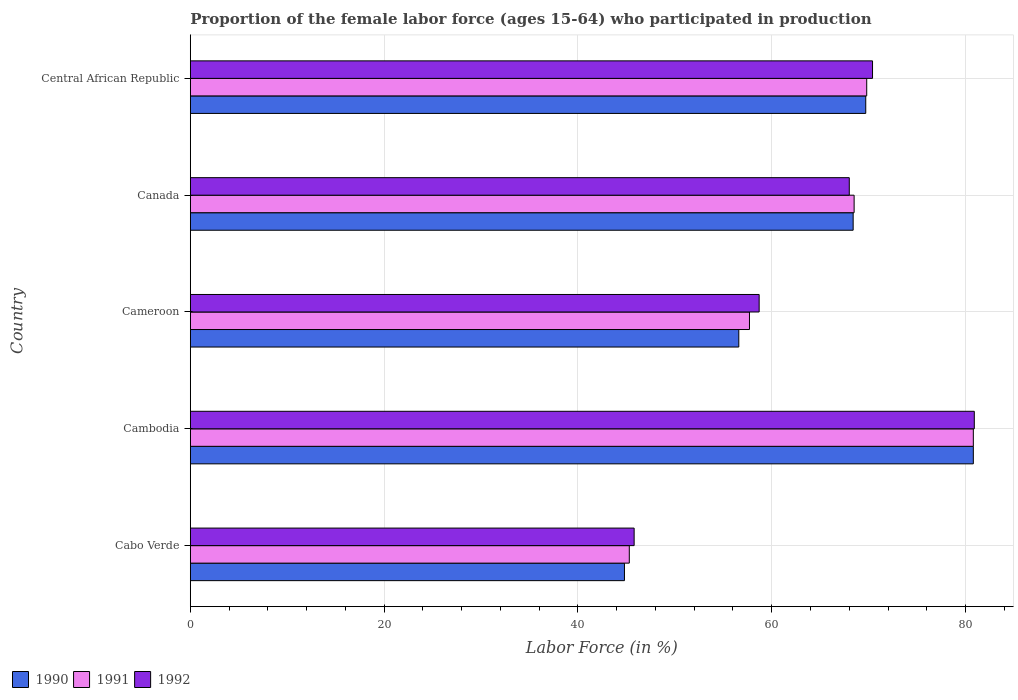How many different coloured bars are there?
Keep it short and to the point. 3. Are the number of bars per tick equal to the number of legend labels?
Offer a very short reply. Yes. Are the number of bars on each tick of the Y-axis equal?
Offer a terse response. Yes. What is the label of the 5th group of bars from the top?
Provide a succinct answer. Cabo Verde. In how many cases, is the number of bars for a given country not equal to the number of legend labels?
Keep it short and to the point. 0. What is the proportion of the female labor force who participated in production in 1992 in Cambodia?
Keep it short and to the point. 80.9. Across all countries, what is the maximum proportion of the female labor force who participated in production in 1991?
Your answer should be compact. 80.8. Across all countries, what is the minimum proportion of the female labor force who participated in production in 1992?
Provide a succinct answer. 45.8. In which country was the proportion of the female labor force who participated in production in 1991 maximum?
Keep it short and to the point. Cambodia. In which country was the proportion of the female labor force who participated in production in 1990 minimum?
Your answer should be compact. Cabo Verde. What is the total proportion of the female labor force who participated in production in 1991 in the graph?
Your answer should be compact. 322.1. What is the difference between the proportion of the female labor force who participated in production in 1990 in Cabo Verde and that in Central African Republic?
Your response must be concise. -24.9. What is the difference between the proportion of the female labor force who participated in production in 1992 in Cameroon and the proportion of the female labor force who participated in production in 1990 in Cabo Verde?
Provide a succinct answer. 13.9. What is the average proportion of the female labor force who participated in production in 1991 per country?
Your response must be concise. 64.42. In how many countries, is the proportion of the female labor force who participated in production in 1991 greater than 44 %?
Your response must be concise. 5. What is the ratio of the proportion of the female labor force who participated in production in 1991 in Canada to that in Central African Republic?
Give a very brief answer. 0.98. Is the proportion of the female labor force who participated in production in 1992 in Cameroon less than that in Canada?
Offer a very short reply. Yes. What is the difference between the highest and the second highest proportion of the female labor force who participated in production in 1991?
Offer a very short reply. 11. What is the difference between the highest and the lowest proportion of the female labor force who participated in production in 1991?
Provide a short and direct response. 35.5. In how many countries, is the proportion of the female labor force who participated in production in 1992 greater than the average proportion of the female labor force who participated in production in 1992 taken over all countries?
Provide a short and direct response. 3. Is the sum of the proportion of the female labor force who participated in production in 1992 in Cambodia and Canada greater than the maximum proportion of the female labor force who participated in production in 1990 across all countries?
Ensure brevity in your answer.  Yes. What does the 3rd bar from the top in Canada represents?
Your response must be concise. 1990. Is it the case that in every country, the sum of the proportion of the female labor force who participated in production in 1991 and proportion of the female labor force who participated in production in 1990 is greater than the proportion of the female labor force who participated in production in 1992?
Offer a very short reply. Yes. Are all the bars in the graph horizontal?
Your answer should be very brief. Yes. How many countries are there in the graph?
Provide a succinct answer. 5. Does the graph contain any zero values?
Keep it short and to the point. No. What is the title of the graph?
Ensure brevity in your answer.  Proportion of the female labor force (ages 15-64) who participated in production. What is the label or title of the X-axis?
Ensure brevity in your answer.  Labor Force (in %). What is the label or title of the Y-axis?
Your answer should be compact. Country. What is the Labor Force (in %) in 1990 in Cabo Verde?
Your answer should be compact. 44.8. What is the Labor Force (in %) in 1991 in Cabo Verde?
Keep it short and to the point. 45.3. What is the Labor Force (in %) of 1992 in Cabo Verde?
Provide a short and direct response. 45.8. What is the Labor Force (in %) of 1990 in Cambodia?
Offer a terse response. 80.8. What is the Labor Force (in %) in 1991 in Cambodia?
Provide a succinct answer. 80.8. What is the Labor Force (in %) of 1992 in Cambodia?
Offer a very short reply. 80.9. What is the Labor Force (in %) in 1990 in Cameroon?
Offer a terse response. 56.6. What is the Labor Force (in %) in 1991 in Cameroon?
Keep it short and to the point. 57.7. What is the Labor Force (in %) in 1992 in Cameroon?
Keep it short and to the point. 58.7. What is the Labor Force (in %) in 1990 in Canada?
Your answer should be compact. 68.4. What is the Labor Force (in %) in 1991 in Canada?
Make the answer very short. 68.5. What is the Labor Force (in %) in 1990 in Central African Republic?
Provide a short and direct response. 69.7. What is the Labor Force (in %) in 1991 in Central African Republic?
Offer a very short reply. 69.8. What is the Labor Force (in %) in 1992 in Central African Republic?
Provide a short and direct response. 70.4. Across all countries, what is the maximum Labor Force (in %) in 1990?
Offer a very short reply. 80.8. Across all countries, what is the maximum Labor Force (in %) of 1991?
Offer a terse response. 80.8. Across all countries, what is the maximum Labor Force (in %) in 1992?
Your answer should be very brief. 80.9. Across all countries, what is the minimum Labor Force (in %) of 1990?
Ensure brevity in your answer.  44.8. Across all countries, what is the minimum Labor Force (in %) of 1991?
Ensure brevity in your answer.  45.3. Across all countries, what is the minimum Labor Force (in %) of 1992?
Your answer should be very brief. 45.8. What is the total Labor Force (in %) of 1990 in the graph?
Your response must be concise. 320.3. What is the total Labor Force (in %) in 1991 in the graph?
Make the answer very short. 322.1. What is the total Labor Force (in %) of 1992 in the graph?
Offer a terse response. 323.8. What is the difference between the Labor Force (in %) in 1990 in Cabo Verde and that in Cambodia?
Provide a succinct answer. -36. What is the difference between the Labor Force (in %) in 1991 in Cabo Verde and that in Cambodia?
Your answer should be compact. -35.5. What is the difference between the Labor Force (in %) of 1992 in Cabo Verde and that in Cambodia?
Keep it short and to the point. -35.1. What is the difference between the Labor Force (in %) of 1990 in Cabo Verde and that in Cameroon?
Your answer should be compact. -11.8. What is the difference between the Labor Force (in %) in 1992 in Cabo Verde and that in Cameroon?
Provide a short and direct response. -12.9. What is the difference between the Labor Force (in %) in 1990 in Cabo Verde and that in Canada?
Your answer should be very brief. -23.6. What is the difference between the Labor Force (in %) in 1991 in Cabo Verde and that in Canada?
Offer a very short reply. -23.2. What is the difference between the Labor Force (in %) of 1992 in Cabo Verde and that in Canada?
Provide a short and direct response. -22.2. What is the difference between the Labor Force (in %) of 1990 in Cabo Verde and that in Central African Republic?
Your answer should be very brief. -24.9. What is the difference between the Labor Force (in %) of 1991 in Cabo Verde and that in Central African Republic?
Your answer should be very brief. -24.5. What is the difference between the Labor Force (in %) of 1992 in Cabo Verde and that in Central African Republic?
Give a very brief answer. -24.6. What is the difference between the Labor Force (in %) of 1990 in Cambodia and that in Cameroon?
Keep it short and to the point. 24.2. What is the difference between the Labor Force (in %) of 1991 in Cambodia and that in Cameroon?
Provide a succinct answer. 23.1. What is the difference between the Labor Force (in %) in 1991 in Cambodia and that in Central African Republic?
Provide a succinct answer. 11. What is the difference between the Labor Force (in %) of 1992 in Cambodia and that in Central African Republic?
Your answer should be compact. 10.5. What is the difference between the Labor Force (in %) in 1990 in Cameroon and that in Central African Republic?
Your answer should be compact. -13.1. What is the difference between the Labor Force (in %) in 1991 in Cameroon and that in Central African Republic?
Your answer should be compact. -12.1. What is the difference between the Labor Force (in %) of 1990 in Canada and that in Central African Republic?
Make the answer very short. -1.3. What is the difference between the Labor Force (in %) in 1990 in Cabo Verde and the Labor Force (in %) in 1991 in Cambodia?
Keep it short and to the point. -36. What is the difference between the Labor Force (in %) in 1990 in Cabo Verde and the Labor Force (in %) in 1992 in Cambodia?
Make the answer very short. -36.1. What is the difference between the Labor Force (in %) of 1991 in Cabo Verde and the Labor Force (in %) of 1992 in Cambodia?
Give a very brief answer. -35.6. What is the difference between the Labor Force (in %) of 1991 in Cabo Verde and the Labor Force (in %) of 1992 in Cameroon?
Provide a short and direct response. -13.4. What is the difference between the Labor Force (in %) of 1990 in Cabo Verde and the Labor Force (in %) of 1991 in Canada?
Offer a terse response. -23.7. What is the difference between the Labor Force (in %) of 1990 in Cabo Verde and the Labor Force (in %) of 1992 in Canada?
Ensure brevity in your answer.  -23.2. What is the difference between the Labor Force (in %) in 1991 in Cabo Verde and the Labor Force (in %) in 1992 in Canada?
Make the answer very short. -22.7. What is the difference between the Labor Force (in %) of 1990 in Cabo Verde and the Labor Force (in %) of 1991 in Central African Republic?
Make the answer very short. -25. What is the difference between the Labor Force (in %) in 1990 in Cabo Verde and the Labor Force (in %) in 1992 in Central African Republic?
Give a very brief answer. -25.6. What is the difference between the Labor Force (in %) of 1991 in Cabo Verde and the Labor Force (in %) of 1992 in Central African Republic?
Your answer should be compact. -25.1. What is the difference between the Labor Force (in %) in 1990 in Cambodia and the Labor Force (in %) in 1991 in Cameroon?
Your answer should be very brief. 23.1. What is the difference between the Labor Force (in %) in 1990 in Cambodia and the Labor Force (in %) in 1992 in Cameroon?
Your answer should be very brief. 22.1. What is the difference between the Labor Force (in %) in 1991 in Cambodia and the Labor Force (in %) in 1992 in Cameroon?
Provide a short and direct response. 22.1. What is the difference between the Labor Force (in %) in 1990 in Cambodia and the Labor Force (in %) in 1992 in Central African Republic?
Give a very brief answer. 10.4. What is the difference between the Labor Force (in %) in 1991 in Cambodia and the Labor Force (in %) in 1992 in Central African Republic?
Offer a terse response. 10.4. What is the difference between the Labor Force (in %) of 1990 in Cameroon and the Labor Force (in %) of 1992 in Canada?
Offer a terse response. -11.4. What is the difference between the Labor Force (in %) in 1991 in Cameroon and the Labor Force (in %) in 1992 in Canada?
Ensure brevity in your answer.  -10.3. What is the difference between the Labor Force (in %) in 1991 in Canada and the Labor Force (in %) in 1992 in Central African Republic?
Provide a succinct answer. -1.9. What is the average Labor Force (in %) in 1990 per country?
Keep it short and to the point. 64.06. What is the average Labor Force (in %) of 1991 per country?
Your answer should be very brief. 64.42. What is the average Labor Force (in %) in 1992 per country?
Your response must be concise. 64.76. What is the difference between the Labor Force (in %) in 1990 and Labor Force (in %) in 1991 in Cabo Verde?
Offer a terse response. -0.5. What is the difference between the Labor Force (in %) in 1990 and Labor Force (in %) in 1992 in Cabo Verde?
Your response must be concise. -1. What is the difference between the Labor Force (in %) of 1991 and Labor Force (in %) of 1992 in Cabo Verde?
Your response must be concise. -0.5. What is the difference between the Labor Force (in %) in 1990 and Labor Force (in %) in 1992 in Cambodia?
Ensure brevity in your answer.  -0.1. What is the difference between the Labor Force (in %) of 1991 and Labor Force (in %) of 1992 in Cambodia?
Provide a succinct answer. -0.1. What is the difference between the Labor Force (in %) in 1990 and Labor Force (in %) in 1992 in Cameroon?
Offer a very short reply. -2.1. What is the difference between the Labor Force (in %) of 1990 and Labor Force (in %) of 1991 in Canada?
Your answer should be compact. -0.1. What is the difference between the Labor Force (in %) in 1990 and Labor Force (in %) in 1991 in Central African Republic?
Provide a succinct answer. -0.1. What is the difference between the Labor Force (in %) in 1991 and Labor Force (in %) in 1992 in Central African Republic?
Ensure brevity in your answer.  -0.6. What is the ratio of the Labor Force (in %) of 1990 in Cabo Verde to that in Cambodia?
Offer a very short reply. 0.55. What is the ratio of the Labor Force (in %) of 1991 in Cabo Verde to that in Cambodia?
Your response must be concise. 0.56. What is the ratio of the Labor Force (in %) in 1992 in Cabo Verde to that in Cambodia?
Keep it short and to the point. 0.57. What is the ratio of the Labor Force (in %) of 1990 in Cabo Verde to that in Cameroon?
Keep it short and to the point. 0.79. What is the ratio of the Labor Force (in %) of 1991 in Cabo Verde to that in Cameroon?
Provide a short and direct response. 0.79. What is the ratio of the Labor Force (in %) in 1992 in Cabo Verde to that in Cameroon?
Ensure brevity in your answer.  0.78. What is the ratio of the Labor Force (in %) of 1990 in Cabo Verde to that in Canada?
Make the answer very short. 0.66. What is the ratio of the Labor Force (in %) of 1991 in Cabo Verde to that in Canada?
Make the answer very short. 0.66. What is the ratio of the Labor Force (in %) in 1992 in Cabo Verde to that in Canada?
Offer a terse response. 0.67. What is the ratio of the Labor Force (in %) in 1990 in Cabo Verde to that in Central African Republic?
Give a very brief answer. 0.64. What is the ratio of the Labor Force (in %) of 1991 in Cabo Verde to that in Central African Republic?
Keep it short and to the point. 0.65. What is the ratio of the Labor Force (in %) in 1992 in Cabo Verde to that in Central African Republic?
Keep it short and to the point. 0.65. What is the ratio of the Labor Force (in %) of 1990 in Cambodia to that in Cameroon?
Offer a terse response. 1.43. What is the ratio of the Labor Force (in %) in 1991 in Cambodia to that in Cameroon?
Your answer should be very brief. 1.4. What is the ratio of the Labor Force (in %) in 1992 in Cambodia to that in Cameroon?
Offer a terse response. 1.38. What is the ratio of the Labor Force (in %) of 1990 in Cambodia to that in Canada?
Ensure brevity in your answer.  1.18. What is the ratio of the Labor Force (in %) in 1991 in Cambodia to that in Canada?
Give a very brief answer. 1.18. What is the ratio of the Labor Force (in %) of 1992 in Cambodia to that in Canada?
Your answer should be compact. 1.19. What is the ratio of the Labor Force (in %) of 1990 in Cambodia to that in Central African Republic?
Provide a short and direct response. 1.16. What is the ratio of the Labor Force (in %) of 1991 in Cambodia to that in Central African Republic?
Your answer should be very brief. 1.16. What is the ratio of the Labor Force (in %) in 1992 in Cambodia to that in Central African Republic?
Your answer should be very brief. 1.15. What is the ratio of the Labor Force (in %) in 1990 in Cameroon to that in Canada?
Your answer should be compact. 0.83. What is the ratio of the Labor Force (in %) of 1991 in Cameroon to that in Canada?
Make the answer very short. 0.84. What is the ratio of the Labor Force (in %) of 1992 in Cameroon to that in Canada?
Offer a very short reply. 0.86. What is the ratio of the Labor Force (in %) of 1990 in Cameroon to that in Central African Republic?
Your answer should be compact. 0.81. What is the ratio of the Labor Force (in %) in 1991 in Cameroon to that in Central African Republic?
Provide a succinct answer. 0.83. What is the ratio of the Labor Force (in %) in 1992 in Cameroon to that in Central African Republic?
Provide a succinct answer. 0.83. What is the ratio of the Labor Force (in %) of 1990 in Canada to that in Central African Republic?
Provide a short and direct response. 0.98. What is the ratio of the Labor Force (in %) in 1991 in Canada to that in Central African Republic?
Your answer should be compact. 0.98. What is the ratio of the Labor Force (in %) in 1992 in Canada to that in Central African Republic?
Your answer should be compact. 0.97. What is the difference between the highest and the lowest Labor Force (in %) of 1991?
Your answer should be very brief. 35.5. What is the difference between the highest and the lowest Labor Force (in %) in 1992?
Give a very brief answer. 35.1. 